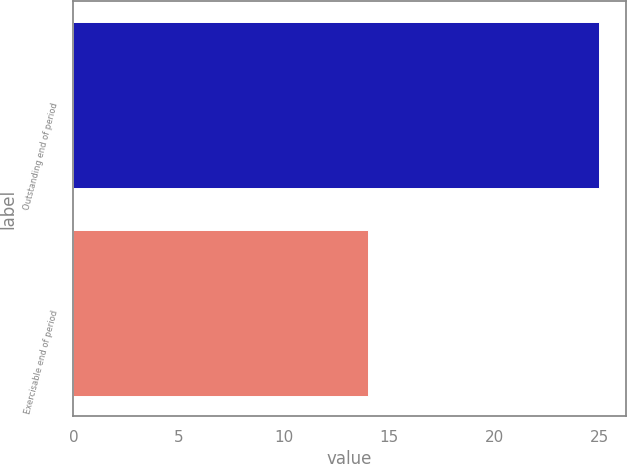<chart> <loc_0><loc_0><loc_500><loc_500><bar_chart><fcel>Outstanding end of period<fcel>Exercisable end of period<nl><fcel>25<fcel>14<nl></chart> 